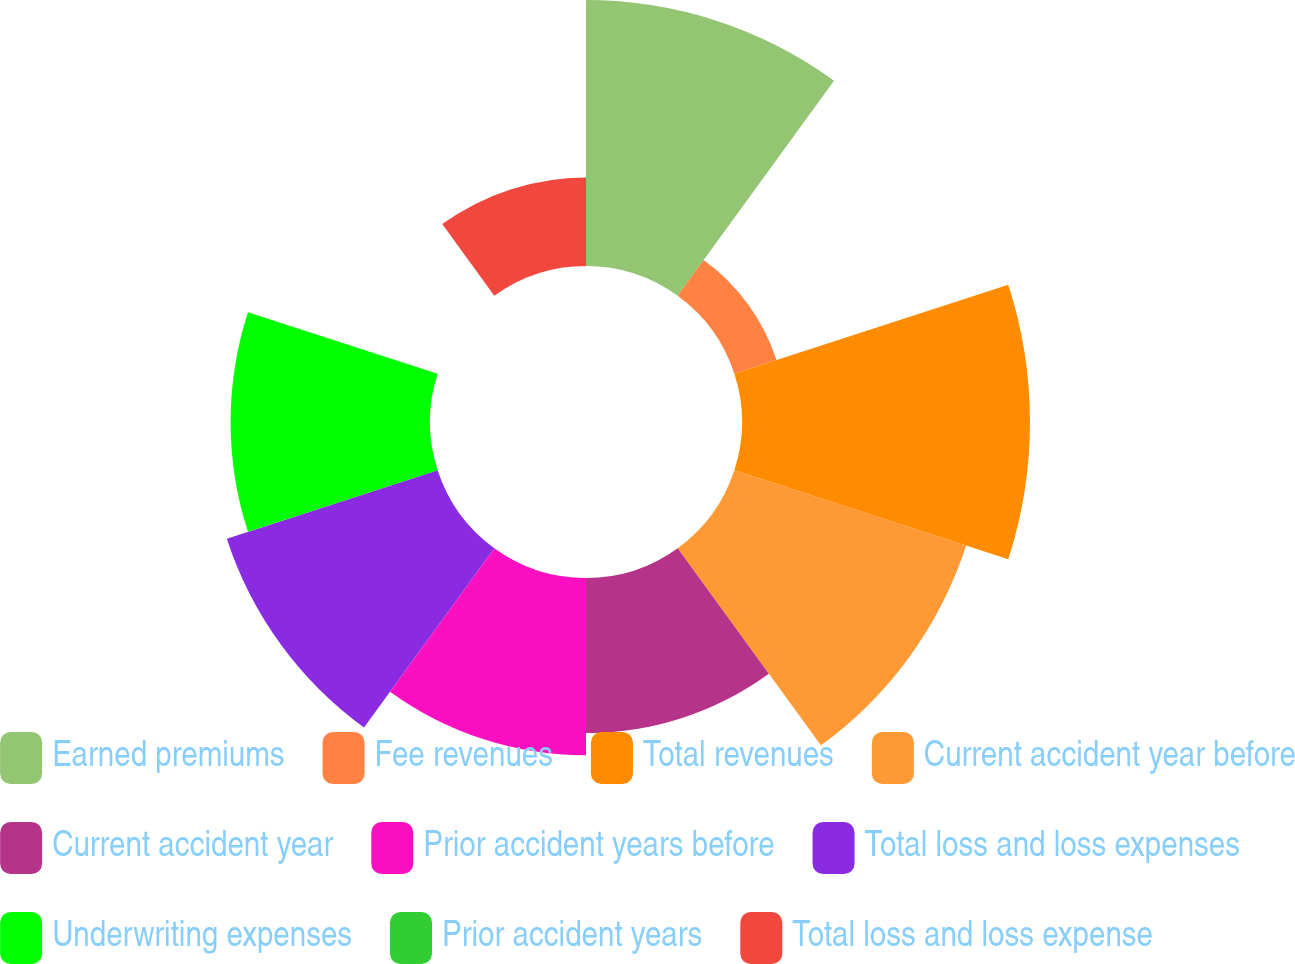Convert chart to OTSL. <chart><loc_0><loc_0><loc_500><loc_500><pie_chart><fcel>Earned premiums<fcel>Fee revenues<fcel>Total revenues<fcel>Current accident year before<fcel>Current accident year<fcel>Prior accident years before<fcel>Total loss and loss expenses<fcel>Underwriting expenses<fcel>Prior accident years<fcel>Total loss and loss expense<nl><fcel>15.79%<fcel>2.63%<fcel>17.1%<fcel>14.47%<fcel>9.21%<fcel>10.53%<fcel>13.16%<fcel>11.84%<fcel>0.0%<fcel>5.26%<nl></chart> 